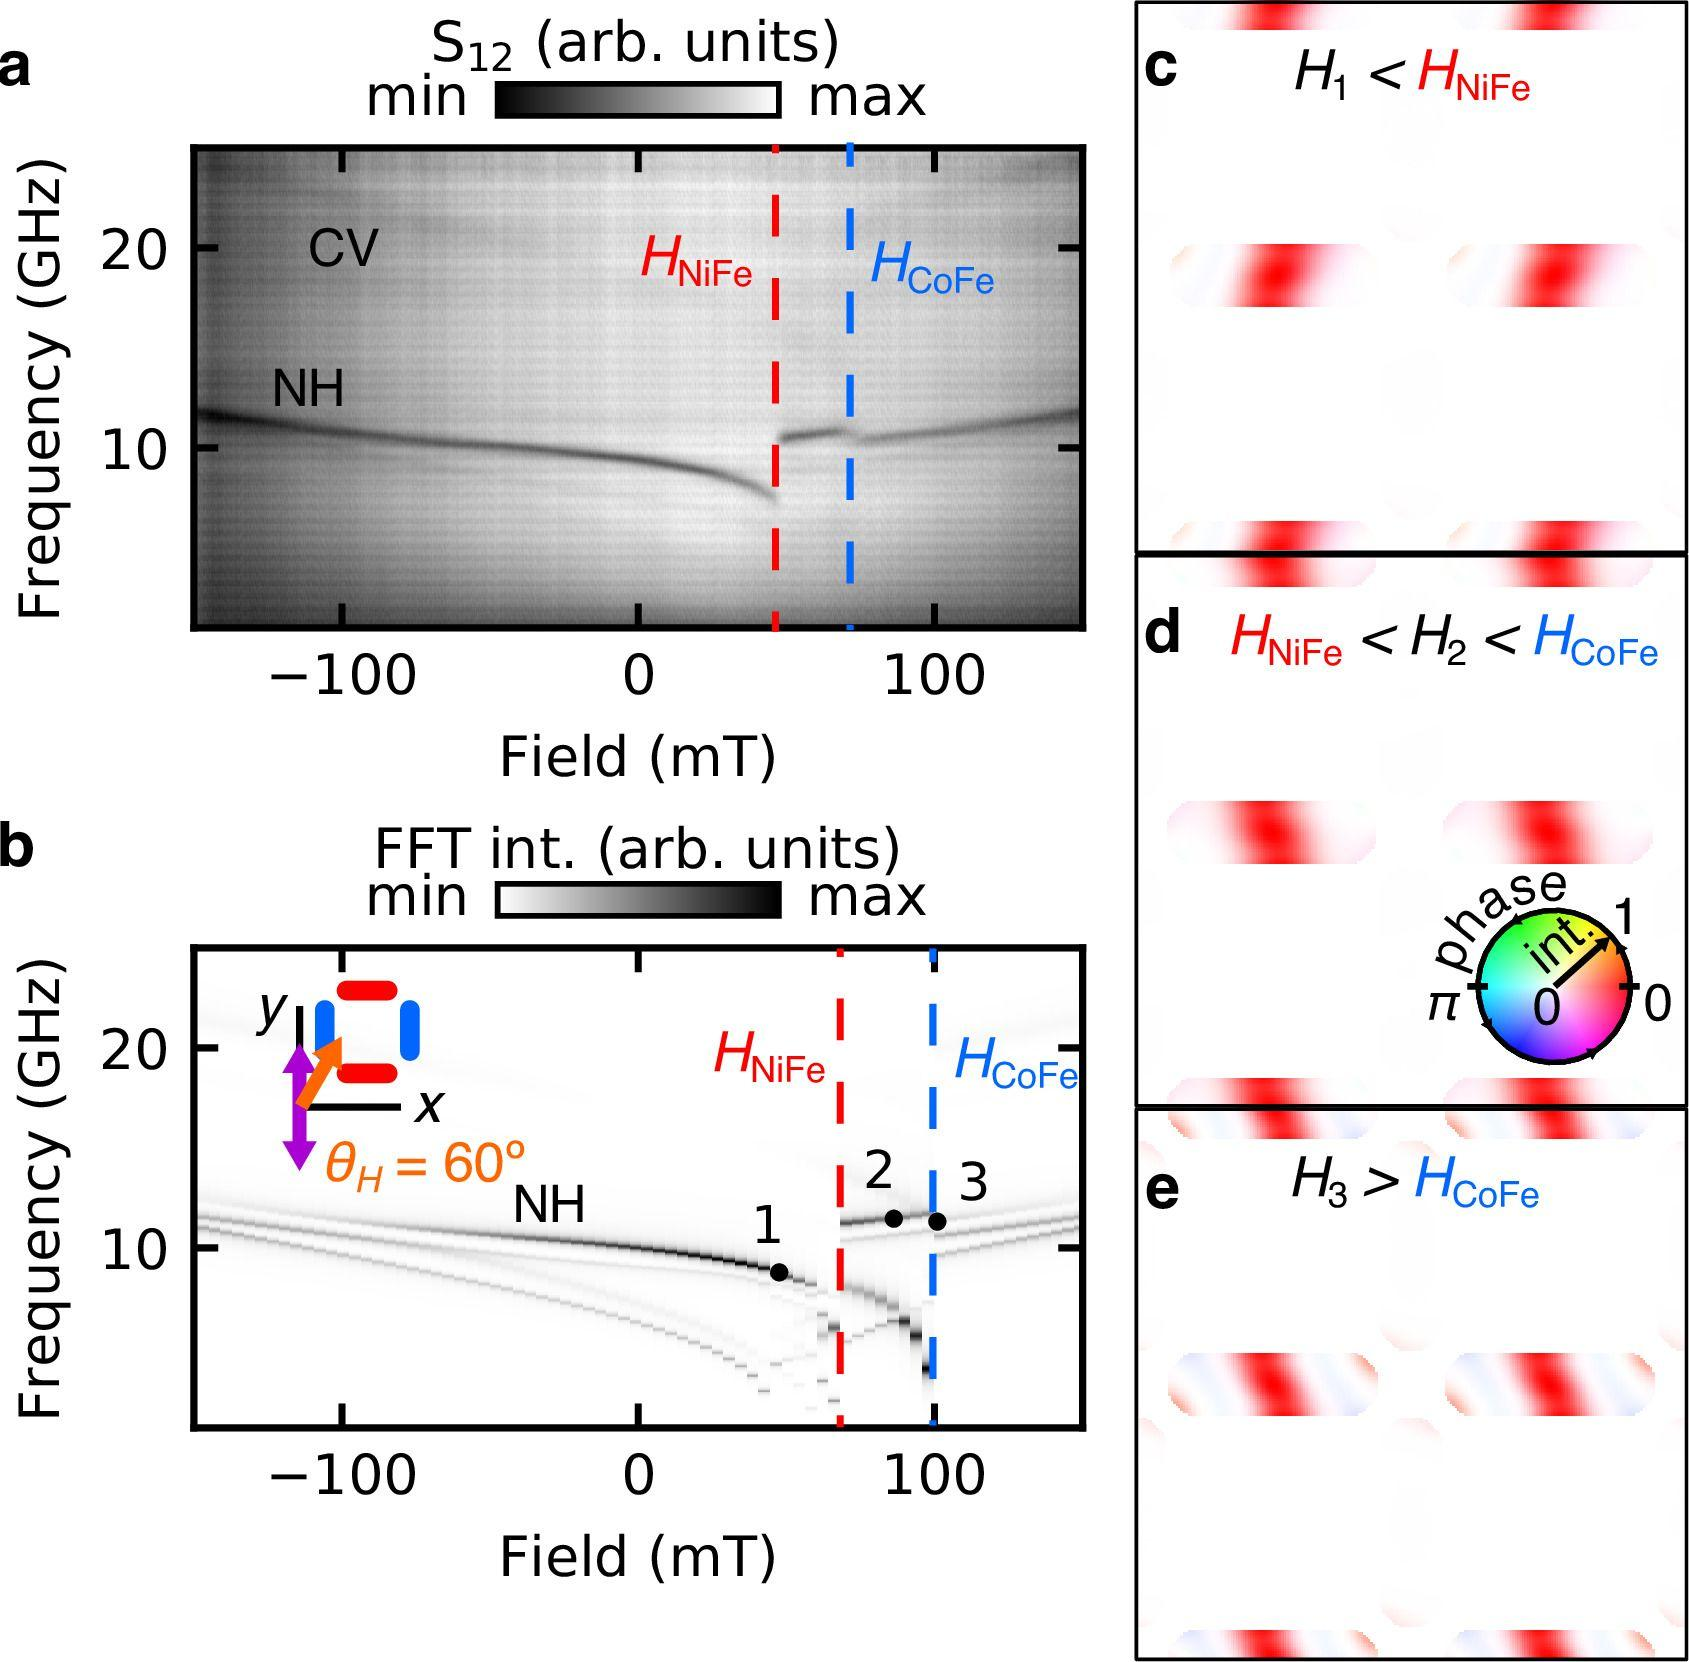Based on panels c, d, and e, what can be inferred about the relationship between \( H_1 \), \( H_2 \), and \( H_3 \) in relation to \( H_{NiFe} \) and \( H_{CoFe} \)? A. \( H_1 > H_{NiFe} \) and \( H_3 > H_{CoFe} \) B. \( H_1 < H_{NiFe} \) and \( H_3 < H_{CoFe} \) C. \( H_1 < H_{NiFe} \) and \( H_3 > H_{CoFe} \) D. \( H_2 < H_{NiFe} \) and \( H_3 < H_{CoFe} \) Panels c, d, and e show different field strengths (labeled \( H_1 \), \( H_2 \), and \( H_3 \)) in relation to \( H_{NiFe} \) and \( H_{CoFe} \). Panel c shows \( H_1 \) with respect to \( H_{NiFe} \), indicating it is less than \( H_{NiFe} \). Panel d shows \( H_{NiFe} < H_2 < H_{CoFe} \), and panel e indicates that \( H_3 \) is greater than \( H_{CoFe} \). Therefore, \( H_1 \) is less than \( H_{NiFe} \), and \( H_3 \) is greater than \( H_{CoFe} \). Therefore, the correct answer is C. 